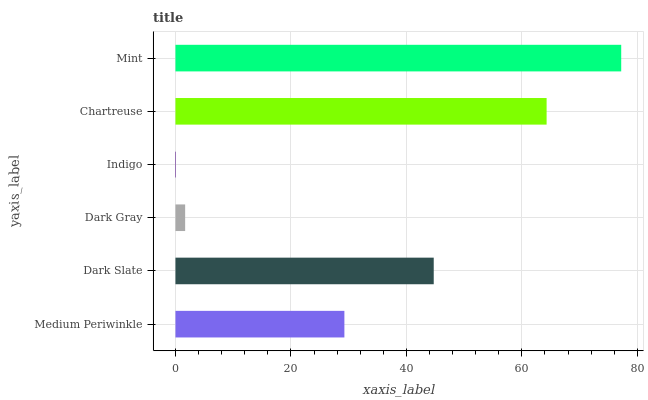Is Indigo the minimum?
Answer yes or no. Yes. Is Mint the maximum?
Answer yes or no. Yes. Is Dark Slate the minimum?
Answer yes or no. No. Is Dark Slate the maximum?
Answer yes or no. No. Is Dark Slate greater than Medium Periwinkle?
Answer yes or no. Yes. Is Medium Periwinkle less than Dark Slate?
Answer yes or no. Yes. Is Medium Periwinkle greater than Dark Slate?
Answer yes or no. No. Is Dark Slate less than Medium Periwinkle?
Answer yes or no. No. Is Dark Slate the high median?
Answer yes or no. Yes. Is Medium Periwinkle the low median?
Answer yes or no. Yes. Is Medium Periwinkle the high median?
Answer yes or no. No. Is Dark Slate the low median?
Answer yes or no. No. 